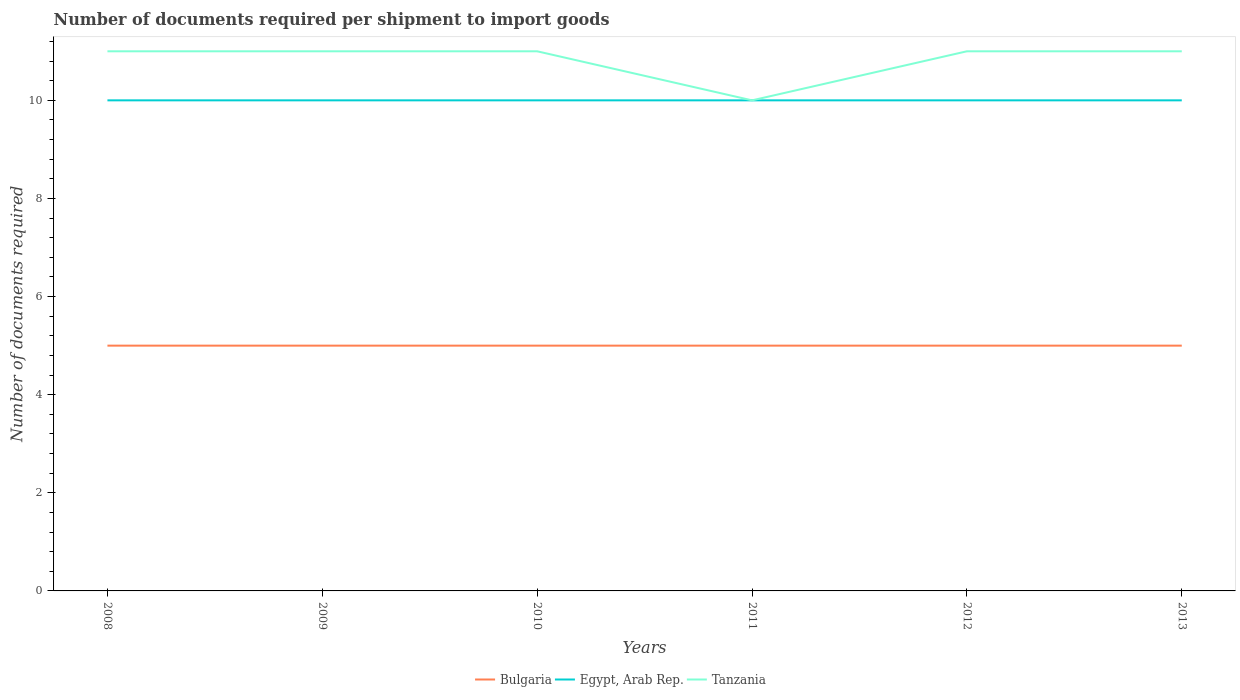How many different coloured lines are there?
Keep it short and to the point. 3. Does the line corresponding to Tanzania intersect with the line corresponding to Egypt, Arab Rep.?
Give a very brief answer. Yes. Is the number of lines equal to the number of legend labels?
Your response must be concise. Yes. Across all years, what is the maximum number of documents required per shipment to import goods in Bulgaria?
Make the answer very short. 5. What is the total number of documents required per shipment to import goods in Tanzania in the graph?
Provide a succinct answer. 0. What is the difference between the highest and the lowest number of documents required per shipment to import goods in Bulgaria?
Ensure brevity in your answer.  0. How many lines are there?
Provide a succinct answer. 3. How many years are there in the graph?
Ensure brevity in your answer.  6. Are the values on the major ticks of Y-axis written in scientific E-notation?
Offer a very short reply. No. Does the graph contain any zero values?
Ensure brevity in your answer.  No. How are the legend labels stacked?
Offer a very short reply. Horizontal. What is the title of the graph?
Provide a short and direct response. Number of documents required per shipment to import goods. Does "Germany" appear as one of the legend labels in the graph?
Give a very brief answer. No. What is the label or title of the Y-axis?
Provide a short and direct response. Number of documents required. What is the Number of documents required of Bulgaria in 2008?
Ensure brevity in your answer.  5. What is the Number of documents required of Bulgaria in 2009?
Offer a very short reply. 5. What is the Number of documents required in Egypt, Arab Rep. in 2009?
Your response must be concise. 10. What is the Number of documents required of Egypt, Arab Rep. in 2010?
Your answer should be compact. 10. What is the Number of documents required in Tanzania in 2010?
Provide a succinct answer. 11. What is the Number of documents required in Egypt, Arab Rep. in 2012?
Your answer should be compact. 10. What is the Number of documents required of Bulgaria in 2013?
Keep it short and to the point. 5. Across all years, what is the maximum Number of documents required in Bulgaria?
Offer a terse response. 5. Across all years, what is the minimum Number of documents required in Tanzania?
Give a very brief answer. 10. What is the total Number of documents required in Bulgaria in the graph?
Your answer should be very brief. 30. What is the total Number of documents required in Egypt, Arab Rep. in the graph?
Make the answer very short. 60. What is the total Number of documents required of Tanzania in the graph?
Your answer should be very brief. 65. What is the difference between the Number of documents required of Bulgaria in 2008 and that in 2009?
Ensure brevity in your answer.  0. What is the difference between the Number of documents required of Tanzania in 2008 and that in 2010?
Provide a short and direct response. 0. What is the difference between the Number of documents required of Egypt, Arab Rep. in 2008 and that in 2011?
Offer a very short reply. 0. What is the difference between the Number of documents required in Tanzania in 2008 and that in 2011?
Offer a terse response. 1. What is the difference between the Number of documents required of Bulgaria in 2008 and that in 2012?
Your answer should be very brief. 0. What is the difference between the Number of documents required in Egypt, Arab Rep. in 2008 and that in 2013?
Keep it short and to the point. 0. What is the difference between the Number of documents required of Tanzania in 2008 and that in 2013?
Ensure brevity in your answer.  0. What is the difference between the Number of documents required in Egypt, Arab Rep. in 2009 and that in 2010?
Offer a terse response. 0. What is the difference between the Number of documents required of Egypt, Arab Rep. in 2009 and that in 2011?
Provide a succinct answer. 0. What is the difference between the Number of documents required of Tanzania in 2009 and that in 2011?
Make the answer very short. 1. What is the difference between the Number of documents required in Bulgaria in 2009 and that in 2012?
Ensure brevity in your answer.  0. What is the difference between the Number of documents required of Tanzania in 2009 and that in 2012?
Offer a terse response. 0. What is the difference between the Number of documents required of Tanzania in 2009 and that in 2013?
Offer a very short reply. 0. What is the difference between the Number of documents required of Bulgaria in 2010 and that in 2011?
Keep it short and to the point. 0. What is the difference between the Number of documents required of Egypt, Arab Rep. in 2010 and that in 2011?
Make the answer very short. 0. What is the difference between the Number of documents required of Tanzania in 2010 and that in 2011?
Give a very brief answer. 1. What is the difference between the Number of documents required in Bulgaria in 2010 and that in 2013?
Your answer should be compact. 0. What is the difference between the Number of documents required of Tanzania in 2010 and that in 2013?
Ensure brevity in your answer.  0. What is the difference between the Number of documents required in Tanzania in 2011 and that in 2012?
Offer a very short reply. -1. What is the difference between the Number of documents required of Bulgaria in 2011 and that in 2013?
Your response must be concise. 0. What is the difference between the Number of documents required in Egypt, Arab Rep. in 2011 and that in 2013?
Provide a short and direct response. 0. What is the difference between the Number of documents required of Tanzania in 2011 and that in 2013?
Your answer should be compact. -1. What is the difference between the Number of documents required in Egypt, Arab Rep. in 2012 and that in 2013?
Make the answer very short. 0. What is the difference between the Number of documents required of Tanzania in 2012 and that in 2013?
Provide a succinct answer. 0. What is the difference between the Number of documents required in Bulgaria in 2008 and the Number of documents required in Egypt, Arab Rep. in 2009?
Make the answer very short. -5. What is the difference between the Number of documents required of Egypt, Arab Rep. in 2008 and the Number of documents required of Tanzania in 2009?
Your response must be concise. -1. What is the difference between the Number of documents required in Bulgaria in 2008 and the Number of documents required in Tanzania in 2010?
Ensure brevity in your answer.  -6. What is the difference between the Number of documents required of Egypt, Arab Rep. in 2008 and the Number of documents required of Tanzania in 2010?
Provide a succinct answer. -1. What is the difference between the Number of documents required of Bulgaria in 2008 and the Number of documents required of Tanzania in 2011?
Offer a very short reply. -5. What is the difference between the Number of documents required of Bulgaria in 2008 and the Number of documents required of Egypt, Arab Rep. in 2012?
Keep it short and to the point. -5. What is the difference between the Number of documents required of Egypt, Arab Rep. in 2008 and the Number of documents required of Tanzania in 2012?
Offer a very short reply. -1. What is the difference between the Number of documents required in Bulgaria in 2008 and the Number of documents required in Tanzania in 2013?
Offer a very short reply. -6. What is the difference between the Number of documents required in Bulgaria in 2009 and the Number of documents required in Egypt, Arab Rep. in 2010?
Your response must be concise. -5. What is the difference between the Number of documents required in Bulgaria in 2009 and the Number of documents required in Tanzania in 2010?
Keep it short and to the point. -6. What is the difference between the Number of documents required in Egypt, Arab Rep. in 2009 and the Number of documents required in Tanzania in 2010?
Your response must be concise. -1. What is the difference between the Number of documents required in Bulgaria in 2009 and the Number of documents required in Egypt, Arab Rep. in 2011?
Your answer should be very brief. -5. What is the difference between the Number of documents required of Egypt, Arab Rep. in 2009 and the Number of documents required of Tanzania in 2012?
Your answer should be compact. -1. What is the difference between the Number of documents required in Bulgaria in 2009 and the Number of documents required in Egypt, Arab Rep. in 2013?
Your response must be concise. -5. What is the difference between the Number of documents required of Bulgaria in 2010 and the Number of documents required of Egypt, Arab Rep. in 2011?
Your response must be concise. -5. What is the difference between the Number of documents required in Bulgaria in 2010 and the Number of documents required in Tanzania in 2011?
Make the answer very short. -5. What is the difference between the Number of documents required of Bulgaria in 2010 and the Number of documents required of Egypt, Arab Rep. in 2012?
Offer a very short reply. -5. What is the difference between the Number of documents required of Egypt, Arab Rep. in 2010 and the Number of documents required of Tanzania in 2012?
Your response must be concise. -1. What is the difference between the Number of documents required in Bulgaria in 2010 and the Number of documents required in Egypt, Arab Rep. in 2013?
Ensure brevity in your answer.  -5. What is the difference between the Number of documents required of Bulgaria in 2010 and the Number of documents required of Tanzania in 2013?
Provide a short and direct response. -6. What is the difference between the Number of documents required in Bulgaria in 2011 and the Number of documents required in Egypt, Arab Rep. in 2012?
Your answer should be very brief. -5. What is the difference between the Number of documents required in Egypt, Arab Rep. in 2011 and the Number of documents required in Tanzania in 2013?
Keep it short and to the point. -1. What is the difference between the Number of documents required in Bulgaria in 2012 and the Number of documents required in Tanzania in 2013?
Your response must be concise. -6. What is the average Number of documents required in Tanzania per year?
Give a very brief answer. 10.83. In the year 2009, what is the difference between the Number of documents required of Bulgaria and Number of documents required of Egypt, Arab Rep.?
Offer a very short reply. -5. In the year 2009, what is the difference between the Number of documents required of Bulgaria and Number of documents required of Tanzania?
Ensure brevity in your answer.  -6. In the year 2010, what is the difference between the Number of documents required of Bulgaria and Number of documents required of Egypt, Arab Rep.?
Keep it short and to the point. -5. In the year 2010, what is the difference between the Number of documents required in Bulgaria and Number of documents required in Tanzania?
Ensure brevity in your answer.  -6. In the year 2010, what is the difference between the Number of documents required of Egypt, Arab Rep. and Number of documents required of Tanzania?
Offer a terse response. -1. In the year 2011, what is the difference between the Number of documents required in Bulgaria and Number of documents required in Egypt, Arab Rep.?
Provide a succinct answer. -5. In the year 2012, what is the difference between the Number of documents required of Bulgaria and Number of documents required of Tanzania?
Provide a short and direct response. -6. In the year 2012, what is the difference between the Number of documents required of Egypt, Arab Rep. and Number of documents required of Tanzania?
Ensure brevity in your answer.  -1. In the year 2013, what is the difference between the Number of documents required in Bulgaria and Number of documents required in Egypt, Arab Rep.?
Offer a terse response. -5. What is the ratio of the Number of documents required in Bulgaria in 2008 to that in 2009?
Give a very brief answer. 1. What is the ratio of the Number of documents required in Egypt, Arab Rep. in 2008 to that in 2009?
Keep it short and to the point. 1. What is the ratio of the Number of documents required in Bulgaria in 2008 to that in 2010?
Keep it short and to the point. 1. What is the ratio of the Number of documents required of Tanzania in 2008 to that in 2010?
Your answer should be compact. 1. What is the ratio of the Number of documents required of Bulgaria in 2008 to that in 2011?
Offer a very short reply. 1. What is the ratio of the Number of documents required in Egypt, Arab Rep. in 2008 to that in 2011?
Make the answer very short. 1. What is the ratio of the Number of documents required in Tanzania in 2008 to that in 2011?
Give a very brief answer. 1.1. What is the ratio of the Number of documents required of Egypt, Arab Rep. in 2008 to that in 2012?
Provide a short and direct response. 1. What is the ratio of the Number of documents required in Bulgaria in 2008 to that in 2013?
Your response must be concise. 1. What is the ratio of the Number of documents required in Egypt, Arab Rep. in 2008 to that in 2013?
Make the answer very short. 1. What is the ratio of the Number of documents required of Tanzania in 2008 to that in 2013?
Keep it short and to the point. 1. What is the ratio of the Number of documents required in Tanzania in 2009 to that in 2010?
Your response must be concise. 1. What is the ratio of the Number of documents required of Tanzania in 2009 to that in 2012?
Your answer should be very brief. 1. What is the ratio of the Number of documents required of Egypt, Arab Rep. in 2009 to that in 2013?
Offer a very short reply. 1. What is the ratio of the Number of documents required of Bulgaria in 2010 to that in 2011?
Provide a succinct answer. 1. What is the ratio of the Number of documents required in Tanzania in 2010 to that in 2011?
Your answer should be compact. 1.1. What is the ratio of the Number of documents required in Bulgaria in 2010 to that in 2012?
Your answer should be very brief. 1. What is the ratio of the Number of documents required of Egypt, Arab Rep. in 2010 to that in 2012?
Offer a terse response. 1. What is the ratio of the Number of documents required of Tanzania in 2010 to that in 2012?
Your response must be concise. 1. What is the ratio of the Number of documents required of Bulgaria in 2010 to that in 2013?
Provide a succinct answer. 1. What is the ratio of the Number of documents required of Tanzania in 2010 to that in 2013?
Keep it short and to the point. 1. What is the ratio of the Number of documents required in Bulgaria in 2011 to that in 2012?
Keep it short and to the point. 1. What is the ratio of the Number of documents required of Egypt, Arab Rep. in 2011 to that in 2012?
Your response must be concise. 1. What is the ratio of the Number of documents required in Egypt, Arab Rep. in 2011 to that in 2013?
Give a very brief answer. 1. What is the ratio of the Number of documents required of Bulgaria in 2012 to that in 2013?
Your answer should be very brief. 1. What is the ratio of the Number of documents required of Tanzania in 2012 to that in 2013?
Offer a very short reply. 1. What is the difference between the highest and the second highest Number of documents required of Bulgaria?
Keep it short and to the point. 0. What is the difference between the highest and the second highest Number of documents required of Egypt, Arab Rep.?
Offer a very short reply. 0. What is the difference between the highest and the second highest Number of documents required in Tanzania?
Ensure brevity in your answer.  0. 